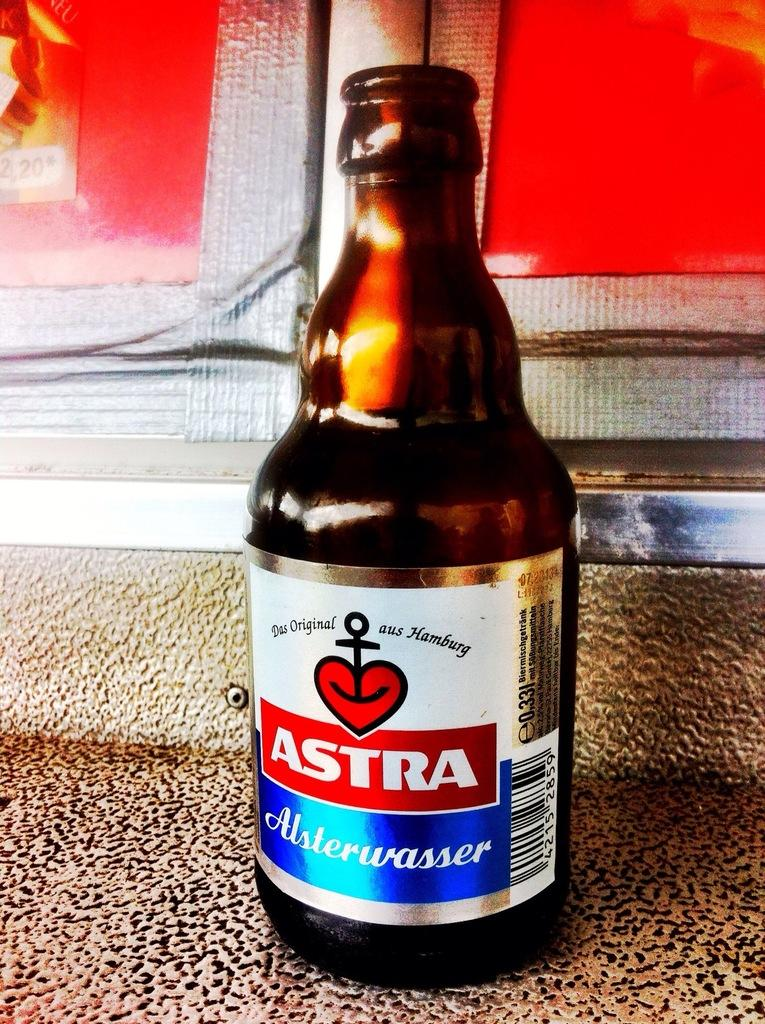<image>
Provide a brief description of the given image. An open bottle of Astra sits on a textured surface. 